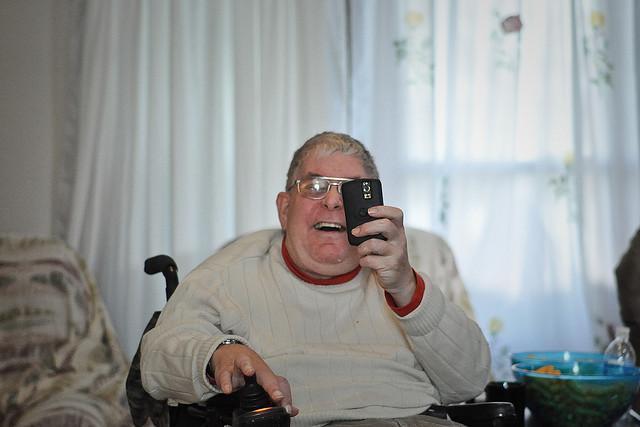How many chairs can be seen?
Give a very brief answer. 2. 